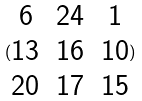<formula> <loc_0><loc_0><loc_500><loc_500>( \begin{matrix} 6 & 2 4 & 1 \\ 1 3 & 1 6 & 1 0 \\ 2 0 & 1 7 & 1 5 \end{matrix} )</formula> 